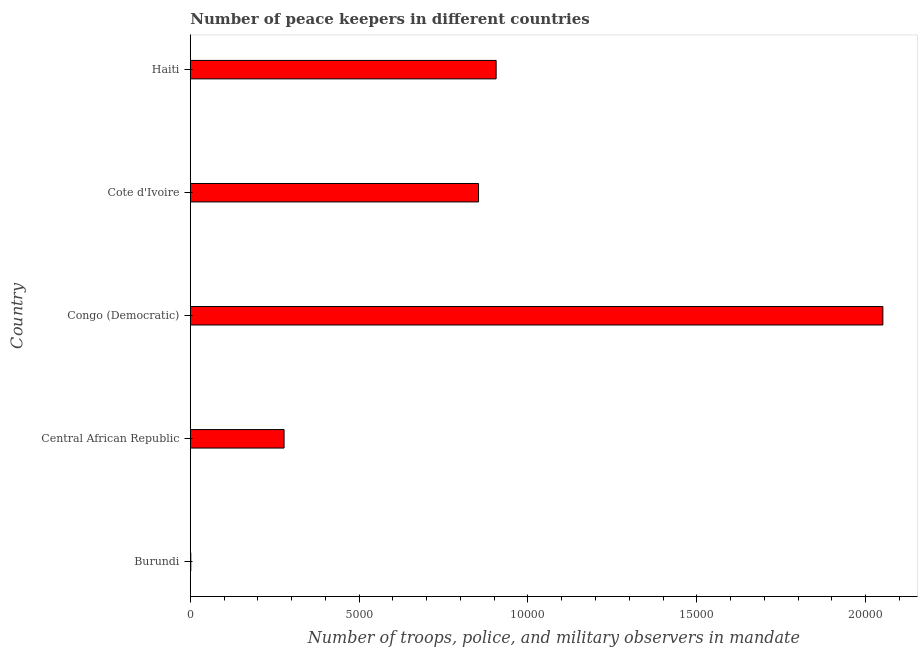Does the graph contain grids?
Offer a very short reply. No. What is the title of the graph?
Provide a short and direct response. Number of peace keepers in different countries. What is the label or title of the X-axis?
Give a very brief answer. Number of troops, police, and military observers in mandate. What is the label or title of the Y-axis?
Provide a succinct answer. Country. What is the number of peace keepers in Congo (Democratic)?
Keep it short and to the point. 2.05e+04. Across all countries, what is the maximum number of peace keepers?
Make the answer very short. 2.05e+04. Across all countries, what is the minimum number of peace keepers?
Ensure brevity in your answer.  15. In which country was the number of peace keepers maximum?
Offer a very short reply. Congo (Democratic). In which country was the number of peace keepers minimum?
Your answer should be compact. Burundi. What is the sum of the number of peace keepers?
Offer a terse response. 4.09e+04. What is the difference between the number of peace keepers in Burundi and Cote d'Ivoire?
Give a very brief answer. -8521. What is the average number of peace keepers per country?
Provide a succinct answer. 8178. What is the median number of peace keepers?
Keep it short and to the point. 8536. What is the ratio of the number of peace keepers in Central African Republic to that in Congo (Democratic)?
Ensure brevity in your answer.  0.14. What is the difference between the highest and the second highest number of peace keepers?
Ensure brevity in your answer.  1.15e+04. What is the difference between the highest and the lowest number of peace keepers?
Your answer should be compact. 2.05e+04. In how many countries, is the number of peace keepers greater than the average number of peace keepers taken over all countries?
Provide a succinct answer. 3. How many bars are there?
Keep it short and to the point. 5. What is the Number of troops, police, and military observers in mandate in Central African Republic?
Offer a terse response. 2777. What is the Number of troops, police, and military observers in mandate of Congo (Democratic)?
Keep it short and to the point. 2.05e+04. What is the Number of troops, police, and military observers in mandate in Cote d'Ivoire?
Ensure brevity in your answer.  8536. What is the Number of troops, police, and military observers in mandate of Haiti?
Provide a succinct answer. 9057. What is the difference between the Number of troops, police, and military observers in mandate in Burundi and Central African Republic?
Offer a terse response. -2762. What is the difference between the Number of troops, police, and military observers in mandate in Burundi and Congo (Democratic)?
Your answer should be compact. -2.05e+04. What is the difference between the Number of troops, police, and military observers in mandate in Burundi and Cote d'Ivoire?
Your response must be concise. -8521. What is the difference between the Number of troops, police, and military observers in mandate in Burundi and Haiti?
Offer a terse response. -9042. What is the difference between the Number of troops, police, and military observers in mandate in Central African Republic and Congo (Democratic)?
Keep it short and to the point. -1.77e+04. What is the difference between the Number of troops, police, and military observers in mandate in Central African Republic and Cote d'Ivoire?
Provide a succinct answer. -5759. What is the difference between the Number of troops, police, and military observers in mandate in Central African Republic and Haiti?
Offer a terse response. -6280. What is the difference between the Number of troops, police, and military observers in mandate in Congo (Democratic) and Cote d'Ivoire?
Your answer should be compact. 1.20e+04. What is the difference between the Number of troops, police, and military observers in mandate in Congo (Democratic) and Haiti?
Provide a succinct answer. 1.15e+04. What is the difference between the Number of troops, police, and military observers in mandate in Cote d'Ivoire and Haiti?
Offer a terse response. -521. What is the ratio of the Number of troops, police, and military observers in mandate in Burundi to that in Central African Republic?
Provide a succinct answer. 0.01. What is the ratio of the Number of troops, police, and military observers in mandate in Burundi to that in Cote d'Ivoire?
Ensure brevity in your answer.  0. What is the ratio of the Number of troops, police, and military observers in mandate in Burundi to that in Haiti?
Ensure brevity in your answer.  0. What is the ratio of the Number of troops, police, and military observers in mandate in Central African Republic to that in Congo (Democratic)?
Your response must be concise. 0.14. What is the ratio of the Number of troops, police, and military observers in mandate in Central African Republic to that in Cote d'Ivoire?
Keep it short and to the point. 0.33. What is the ratio of the Number of troops, police, and military observers in mandate in Central African Republic to that in Haiti?
Offer a terse response. 0.31. What is the ratio of the Number of troops, police, and military observers in mandate in Congo (Democratic) to that in Cote d'Ivoire?
Your answer should be very brief. 2.4. What is the ratio of the Number of troops, police, and military observers in mandate in Congo (Democratic) to that in Haiti?
Offer a very short reply. 2.26. What is the ratio of the Number of troops, police, and military observers in mandate in Cote d'Ivoire to that in Haiti?
Your answer should be very brief. 0.94. 